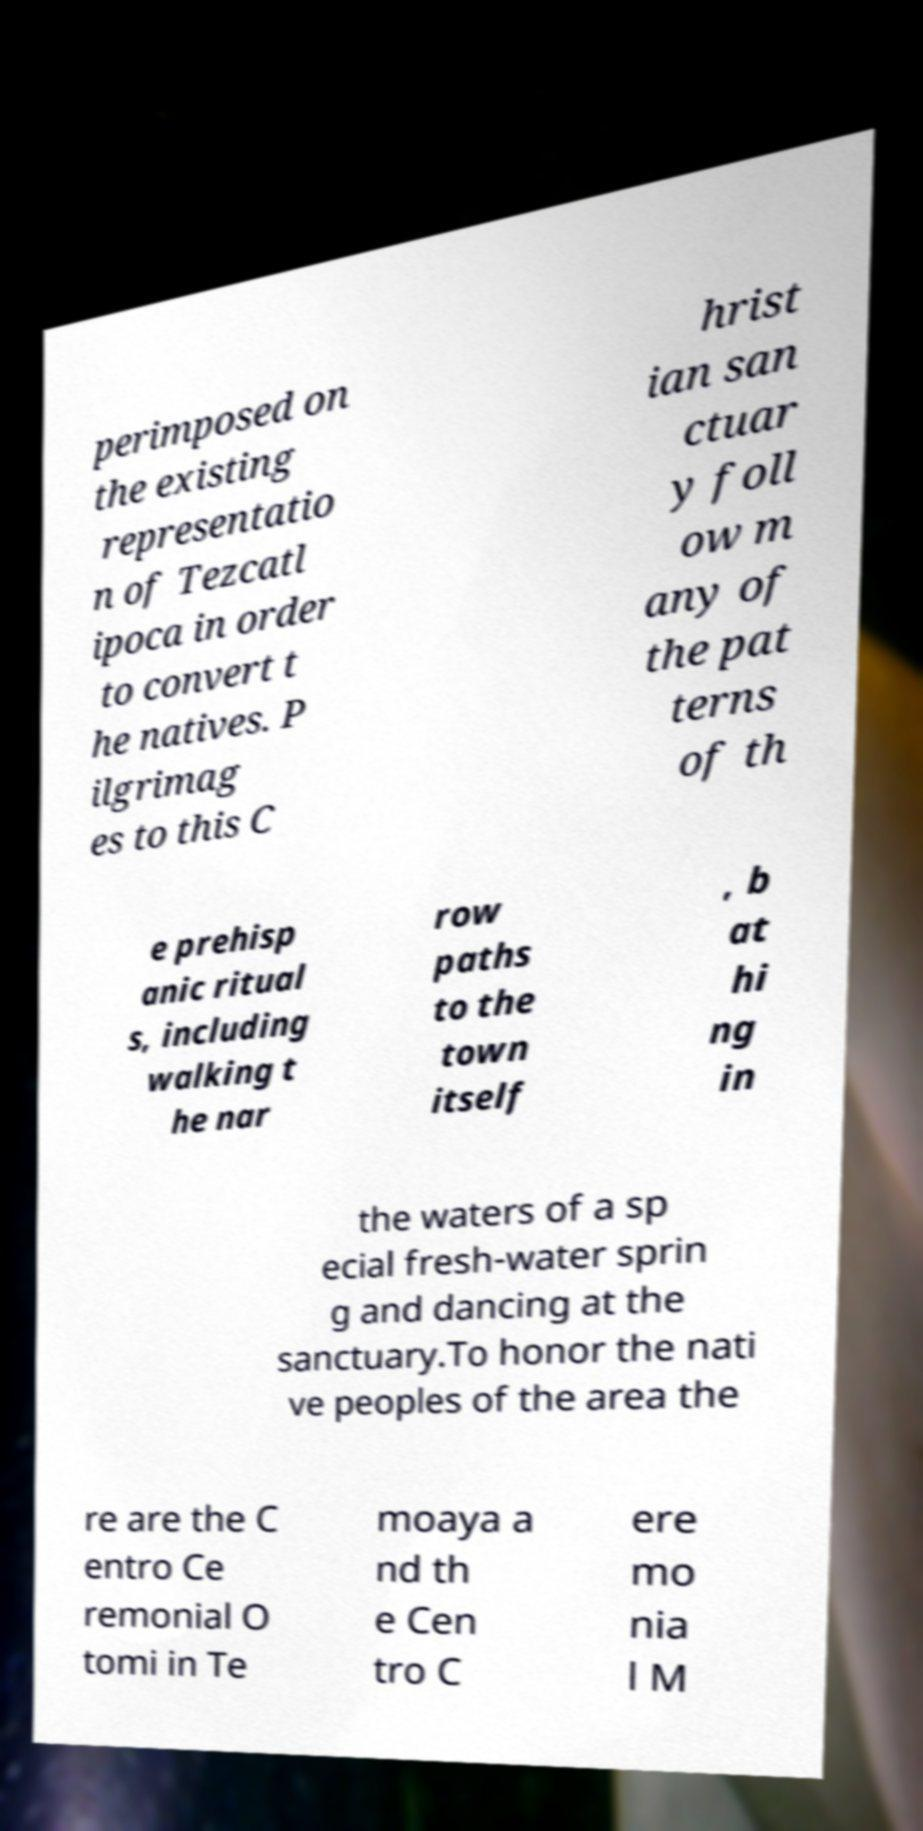I need the written content from this picture converted into text. Can you do that? perimposed on the existing representatio n of Tezcatl ipoca in order to convert t he natives. P ilgrimag es to this C hrist ian san ctuar y foll ow m any of the pat terns of th e prehisp anic ritual s, including walking t he nar row paths to the town itself , b at hi ng in the waters of a sp ecial fresh-water sprin g and dancing at the sanctuary.To honor the nati ve peoples of the area the re are the C entro Ce remonial O tomi in Te moaya a nd th e Cen tro C ere mo nia l M 